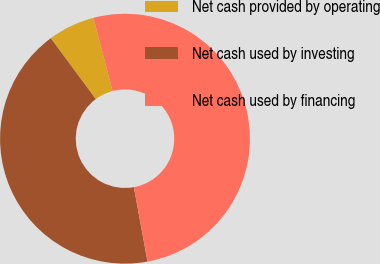Convert chart to OTSL. <chart><loc_0><loc_0><loc_500><loc_500><pie_chart><fcel>Net cash provided by operating<fcel>Net cash used by investing<fcel>Net cash used by financing<nl><fcel>6.06%<fcel>42.76%<fcel>51.18%<nl></chart> 